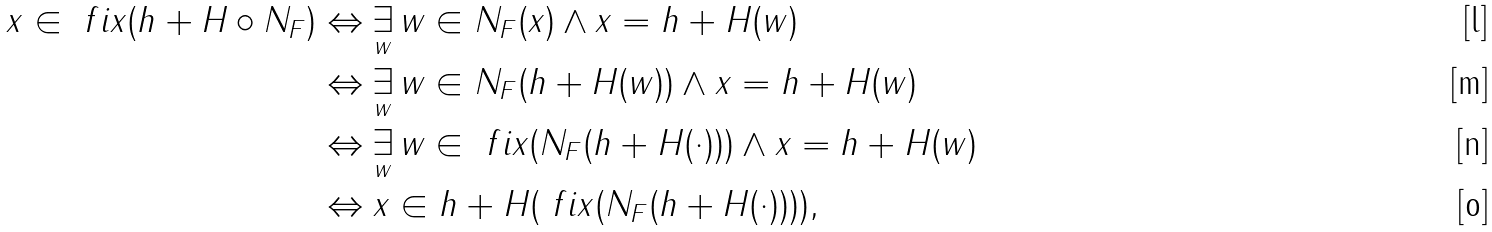Convert formula to latex. <formula><loc_0><loc_0><loc_500><loc_500>x \in \ f i x ( h + H \circ N _ { F } ) & \Leftrightarrow \underset { w } { \exists } \, w \in N _ { F } ( x ) \wedge x = h + H ( w ) \\ & \Leftrightarrow \underset { w } { \exists } \, w \in N _ { F } ( h + H ( w ) ) \wedge x = h + H ( w ) \\ & \Leftrightarrow \underset { w } { \exists } \, w \in \ f i x ( N _ { F } ( h + H ( \cdot ) ) ) \wedge x = h + H ( w ) \\ & \Leftrightarrow x \in h + H ( \ f i x ( N _ { F } ( h + H ( \cdot ) ) ) ) ,</formula> 